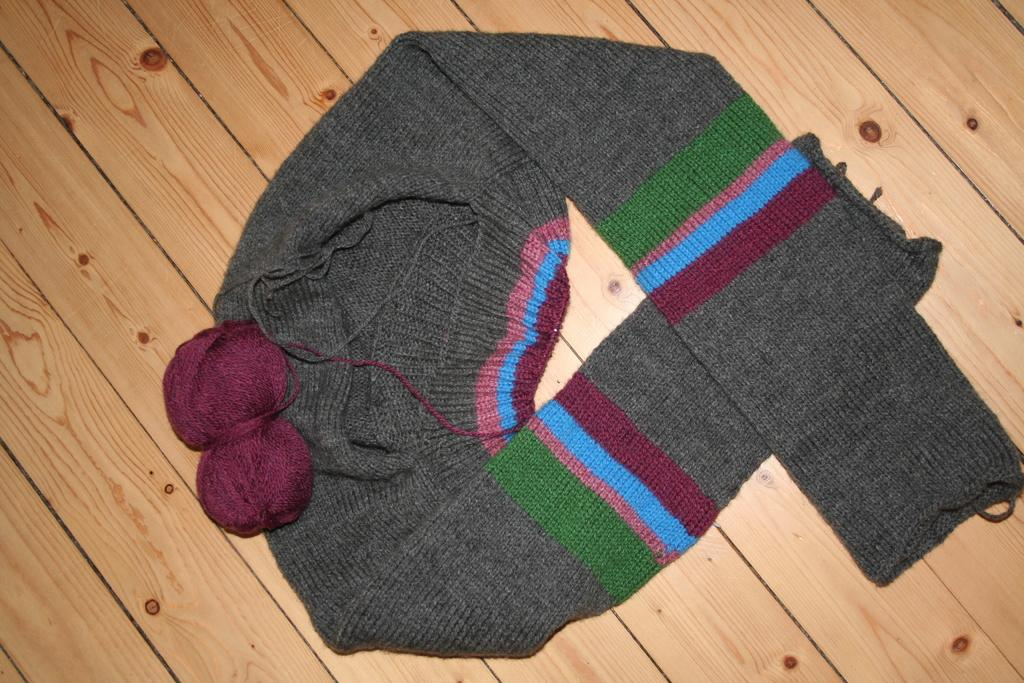What type of material is visible in the image? There is wool present in the image. What item is made from the wool in the image? There is a sweater present in the image. On what surface is the wool and sweater placed? The wool and sweater are placed on a wooden surface. How does the hill in the image affect the rainstorm? There is no hill or rainstorm present in the image; it features wool and a sweater on a wooden surface. 